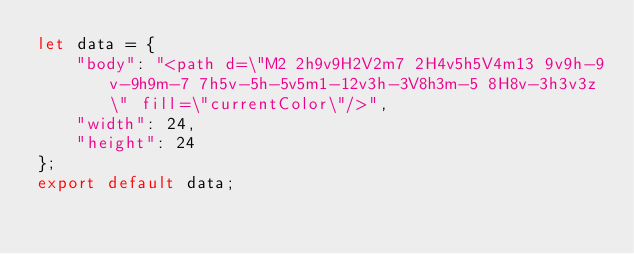Convert code to text. <code><loc_0><loc_0><loc_500><loc_500><_JavaScript_>let data = {
	"body": "<path d=\"M2 2h9v9H2V2m7 2H4v5h5V4m13 9v9h-9v-9h9m-7 7h5v-5h-5v5m1-12v3h-3V8h3m-5 8H8v-3h3v3z\" fill=\"currentColor\"/>",
	"width": 24,
	"height": 24
};
export default data;
</code> 